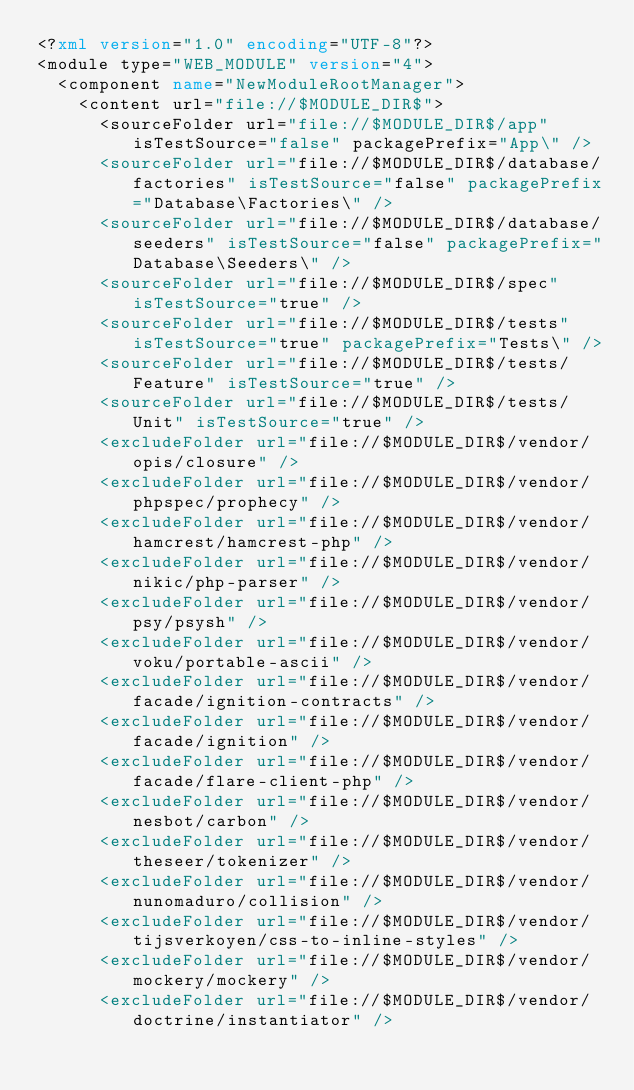Convert code to text. <code><loc_0><loc_0><loc_500><loc_500><_XML_><?xml version="1.0" encoding="UTF-8"?>
<module type="WEB_MODULE" version="4">
  <component name="NewModuleRootManager">
    <content url="file://$MODULE_DIR$">
      <sourceFolder url="file://$MODULE_DIR$/app" isTestSource="false" packagePrefix="App\" />
      <sourceFolder url="file://$MODULE_DIR$/database/factories" isTestSource="false" packagePrefix="Database\Factories\" />
      <sourceFolder url="file://$MODULE_DIR$/database/seeders" isTestSource="false" packagePrefix="Database\Seeders\" />
      <sourceFolder url="file://$MODULE_DIR$/spec" isTestSource="true" />
      <sourceFolder url="file://$MODULE_DIR$/tests" isTestSource="true" packagePrefix="Tests\" />
      <sourceFolder url="file://$MODULE_DIR$/tests/Feature" isTestSource="true" />
      <sourceFolder url="file://$MODULE_DIR$/tests/Unit" isTestSource="true" />
      <excludeFolder url="file://$MODULE_DIR$/vendor/opis/closure" />
      <excludeFolder url="file://$MODULE_DIR$/vendor/phpspec/prophecy" />
      <excludeFolder url="file://$MODULE_DIR$/vendor/hamcrest/hamcrest-php" />
      <excludeFolder url="file://$MODULE_DIR$/vendor/nikic/php-parser" />
      <excludeFolder url="file://$MODULE_DIR$/vendor/psy/psysh" />
      <excludeFolder url="file://$MODULE_DIR$/vendor/voku/portable-ascii" />
      <excludeFolder url="file://$MODULE_DIR$/vendor/facade/ignition-contracts" />
      <excludeFolder url="file://$MODULE_DIR$/vendor/facade/ignition" />
      <excludeFolder url="file://$MODULE_DIR$/vendor/facade/flare-client-php" />
      <excludeFolder url="file://$MODULE_DIR$/vendor/nesbot/carbon" />
      <excludeFolder url="file://$MODULE_DIR$/vendor/theseer/tokenizer" />
      <excludeFolder url="file://$MODULE_DIR$/vendor/nunomaduro/collision" />
      <excludeFolder url="file://$MODULE_DIR$/vendor/tijsverkoyen/css-to-inline-styles" />
      <excludeFolder url="file://$MODULE_DIR$/vendor/mockery/mockery" />
      <excludeFolder url="file://$MODULE_DIR$/vendor/doctrine/instantiator" /></code> 